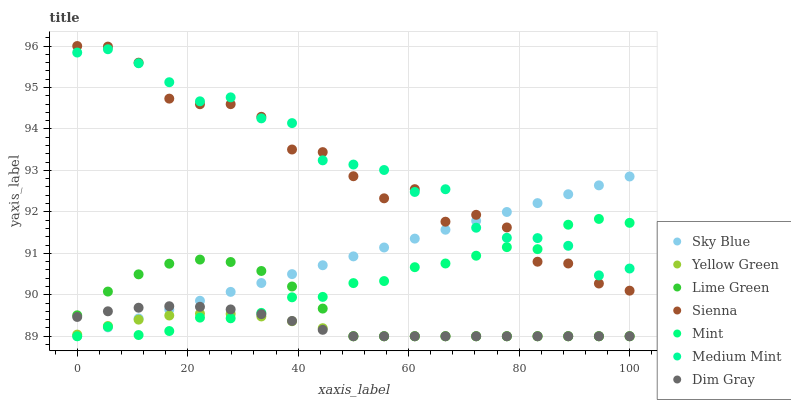Does Yellow Green have the minimum area under the curve?
Answer yes or no. Yes. Does Medium Mint have the maximum area under the curve?
Answer yes or no. Yes. Does Dim Gray have the minimum area under the curve?
Answer yes or no. No. Does Dim Gray have the maximum area under the curve?
Answer yes or no. No. Is Sky Blue the smoothest?
Answer yes or no. Yes. Is Sienna the roughest?
Answer yes or no. Yes. Is Dim Gray the smoothest?
Answer yes or no. No. Is Dim Gray the roughest?
Answer yes or no. No. Does Dim Gray have the lowest value?
Answer yes or no. Yes. Does Sienna have the lowest value?
Answer yes or no. No. Does Sienna have the highest value?
Answer yes or no. Yes. Does Dim Gray have the highest value?
Answer yes or no. No. Is Dim Gray less than Medium Mint?
Answer yes or no. Yes. Is Medium Mint greater than Dim Gray?
Answer yes or no. Yes. Does Lime Green intersect Sky Blue?
Answer yes or no. Yes. Is Lime Green less than Sky Blue?
Answer yes or no. No. Is Lime Green greater than Sky Blue?
Answer yes or no. No. Does Dim Gray intersect Medium Mint?
Answer yes or no. No. 